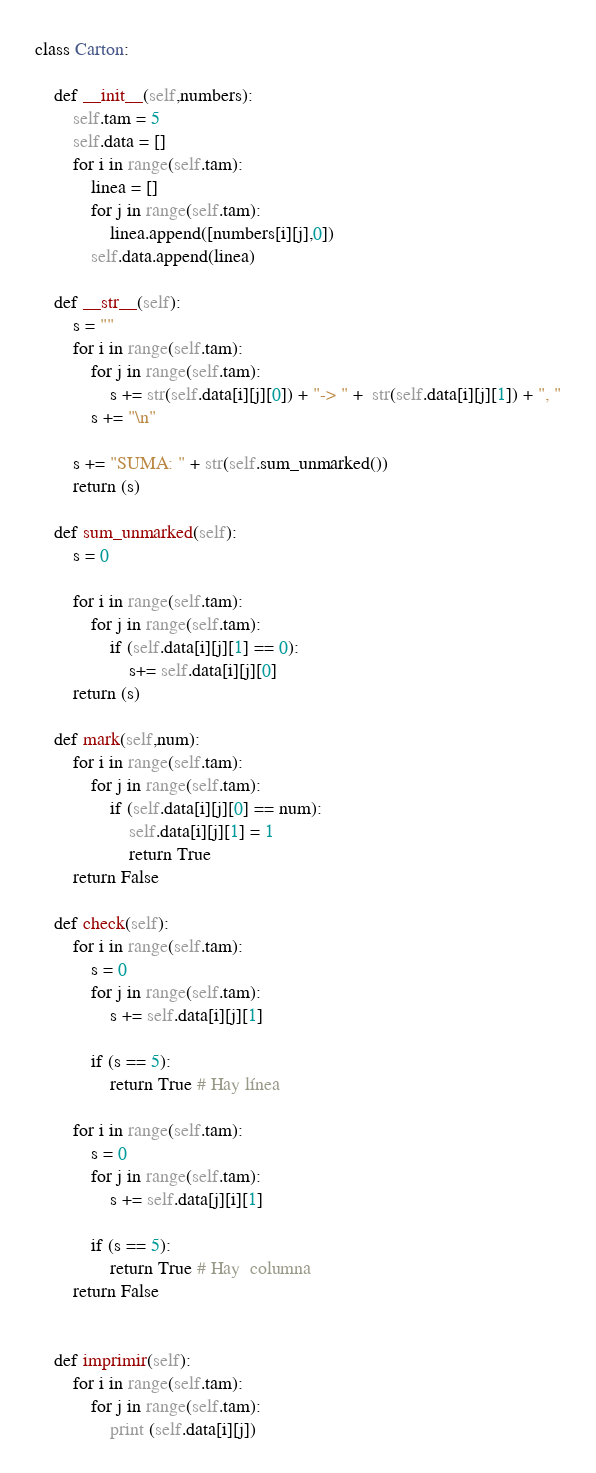<code> <loc_0><loc_0><loc_500><loc_500><_Python_>class Carton:
    
    def __init__(self,numbers):
        self.tam = 5
        self.data = []
        for i in range(self.tam):
            linea = []
            for j in range(self.tam):
                linea.append([numbers[i][j],0])
            self.data.append(linea)

    def __str__(self):
        s = ""
        for i in range(self.tam):
            for j in range(self.tam):
                s += str(self.data[i][j][0]) + "-> " +  str(self.data[i][j][1]) + ", "
            s += "\n"

        s += "SUMA: " + str(self.sum_unmarked())
        return (s)

    def sum_unmarked(self):
        s = 0

        for i in range(self.tam):
            for j in range(self.tam):
                if (self.data[i][j][1] == 0):
                    s+= self.data[i][j][0]
        return (s)
    
    def mark(self,num):
        for i in range(self.tam):
            for j in range(self.tam):
                if (self.data[i][j][0] == num):
                    self.data[i][j][1] = 1
                    return True
        return False
    
    def check(self):
        for i in range(self.tam):
            s = 0
            for j in range(self.tam):
                s += self.data[i][j][1]

            if (s == 5):
                return True # Hay línea
        
        for i in range(self.tam):
            s = 0
            for j in range(self.tam):
                s += self.data[j][i][1]

            if (s == 5):
                return True # Hay  columna
        return False


    def imprimir(self):
        for i in range(self.tam):
            for j in range(self.tam):
                print (self.data[i][j]) </code> 